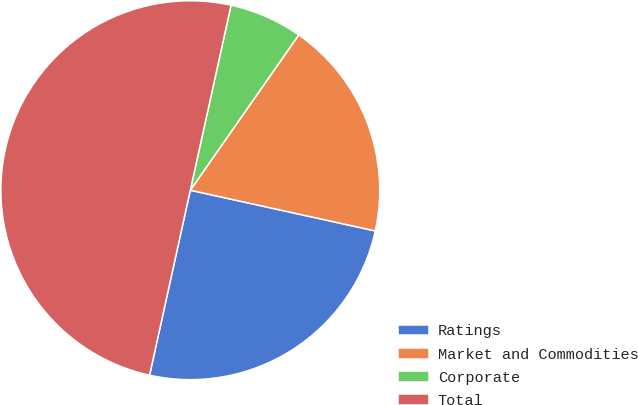<chart> <loc_0><loc_0><loc_500><loc_500><pie_chart><fcel>Ratings<fcel>Market and Commodities<fcel>Corporate<fcel>Total<nl><fcel>25.0%<fcel>18.75%<fcel>6.25%<fcel>50.0%<nl></chart> 